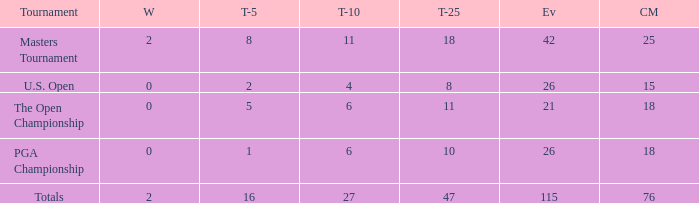What are the largest cuts made when the events are less than 21? None. Give me the full table as a dictionary. {'header': ['Tournament', 'W', 'T-5', 'T-10', 'T-25', 'Ev', 'CM'], 'rows': [['Masters Tournament', '2', '8', '11', '18', '42', '25'], ['U.S. Open', '0', '2', '4', '8', '26', '15'], ['The Open Championship', '0', '5', '6', '11', '21', '18'], ['PGA Championship', '0', '1', '6', '10', '26', '18'], ['Totals', '2', '16', '27', '47', '115', '76']]} 